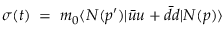Convert formula to latex. <formula><loc_0><loc_0><loc_500><loc_500>\sigma ( t ) \, = \, m _ { 0 } \langle N ( p ^ { \prime } ) | \bar { u } u + \bar { d } { d } | N ( p ) \rangle</formula> 